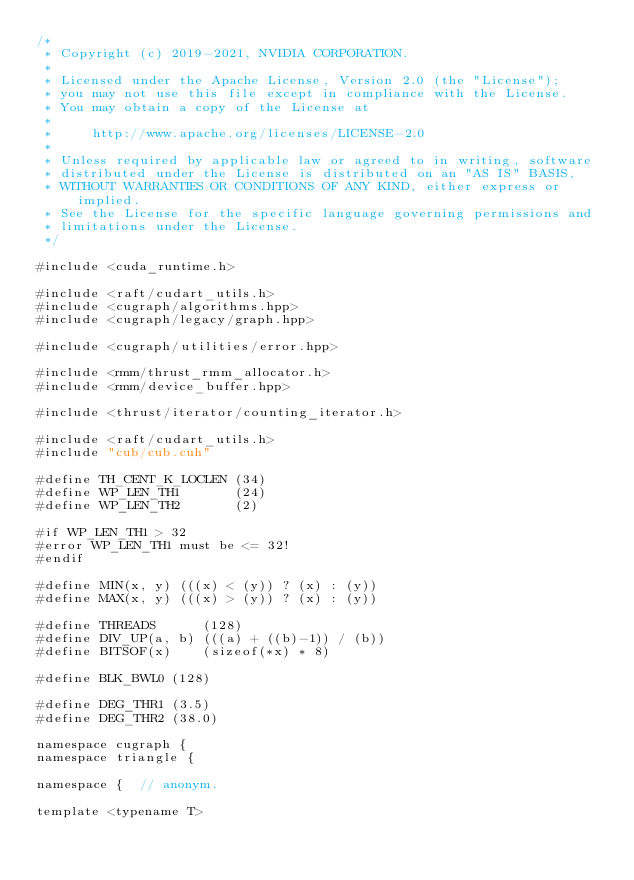Convert code to text. <code><loc_0><loc_0><loc_500><loc_500><_Cuda_>/*
 * Copyright (c) 2019-2021, NVIDIA CORPORATION.
 *
 * Licensed under the Apache License, Version 2.0 (the "License");
 * you may not use this file except in compliance with the License.
 * You may obtain a copy of the License at
 *
 *     http://www.apache.org/licenses/LICENSE-2.0
 *
 * Unless required by applicable law or agreed to in writing, software
 * distributed under the License is distributed on an "AS IS" BASIS,
 * WITHOUT WARRANTIES OR CONDITIONS OF ANY KIND, either express or implied.
 * See the License for the specific language governing permissions and
 * limitations under the License.
 */

#include <cuda_runtime.h>

#include <raft/cudart_utils.h>
#include <cugraph/algorithms.hpp>
#include <cugraph/legacy/graph.hpp>

#include <cugraph/utilities/error.hpp>

#include <rmm/thrust_rmm_allocator.h>
#include <rmm/device_buffer.hpp>

#include <thrust/iterator/counting_iterator.h>

#include <raft/cudart_utils.h>
#include "cub/cub.cuh"

#define TH_CENT_K_LOCLEN (34)
#define WP_LEN_TH1       (24)
#define WP_LEN_TH2       (2)

#if WP_LEN_TH1 > 32
#error WP_LEN_TH1 must be <= 32!
#endif

#define MIN(x, y) (((x) < (y)) ? (x) : (y))
#define MAX(x, y) (((x) > (y)) ? (x) : (y))

#define THREADS      (128)
#define DIV_UP(a, b) (((a) + ((b)-1)) / (b))
#define BITSOF(x)    (sizeof(*x) * 8)

#define BLK_BWL0 (128)

#define DEG_THR1 (3.5)
#define DEG_THR2 (38.0)

namespace cugraph {
namespace triangle {

namespace {  // anonym.

template <typename T></code> 